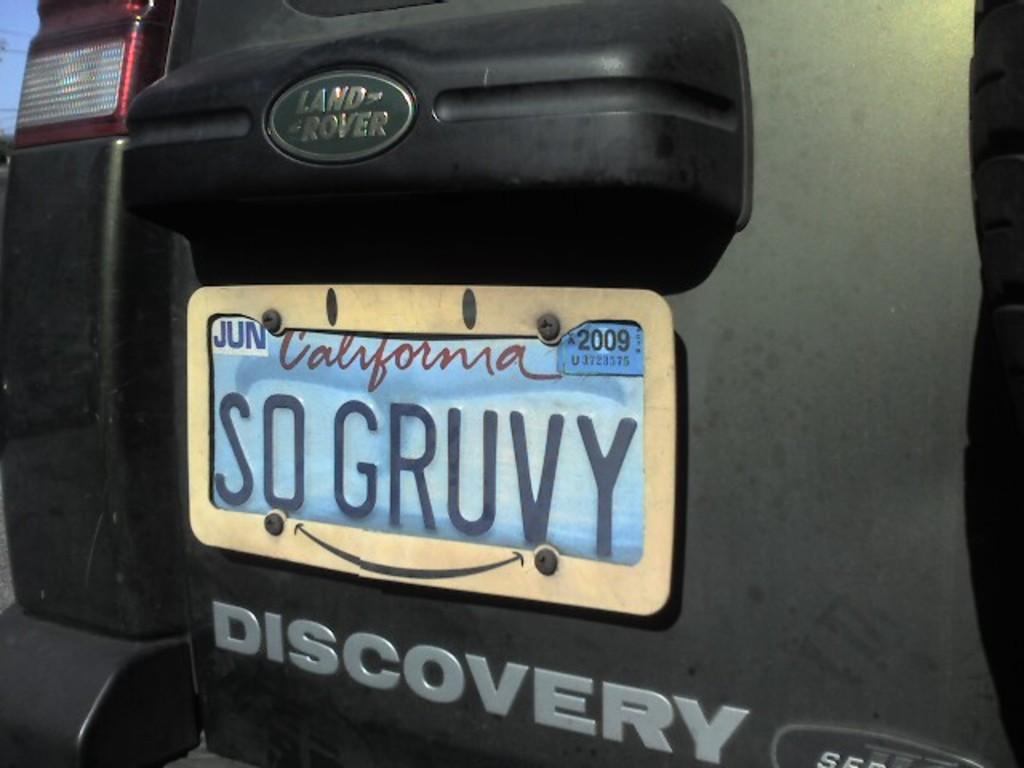<image>
Create a compact narrative representing the image presented. A Land Rover has a SO GRUVY vanity plate. 